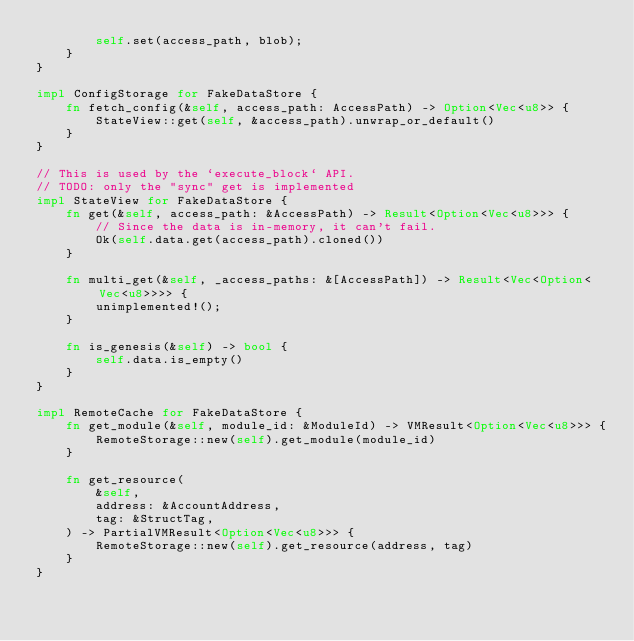<code> <loc_0><loc_0><loc_500><loc_500><_Rust_>        self.set(access_path, blob);
    }
}

impl ConfigStorage for FakeDataStore {
    fn fetch_config(&self, access_path: AccessPath) -> Option<Vec<u8>> {
        StateView::get(self, &access_path).unwrap_or_default()
    }
}

// This is used by the `execute_block` API.
// TODO: only the "sync" get is implemented
impl StateView for FakeDataStore {
    fn get(&self, access_path: &AccessPath) -> Result<Option<Vec<u8>>> {
        // Since the data is in-memory, it can't fail.
        Ok(self.data.get(access_path).cloned())
    }

    fn multi_get(&self, _access_paths: &[AccessPath]) -> Result<Vec<Option<Vec<u8>>>> {
        unimplemented!();
    }

    fn is_genesis(&self) -> bool {
        self.data.is_empty()
    }
}

impl RemoteCache for FakeDataStore {
    fn get_module(&self, module_id: &ModuleId) -> VMResult<Option<Vec<u8>>> {
        RemoteStorage::new(self).get_module(module_id)
    }

    fn get_resource(
        &self,
        address: &AccountAddress,
        tag: &StructTag,
    ) -> PartialVMResult<Option<Vec<u8>>> {
        RemoteStorage::new(self).get_resource(address, tag)
    }
}
</code> 